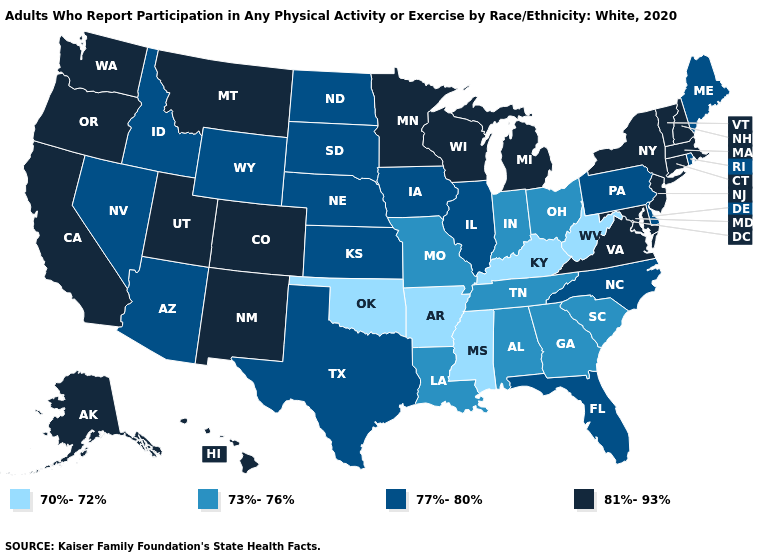What is the value of Montana?
Give a very brief answer. 81%-93%. Name the states that have a value in the range 70%-72%?
Keep it brief. Arkansas, Kentucky, Mississippi, Oklahoma, West Virginia. Name the states that have a value in the range 77%-80%?
Answer briefly. Arizona, Delaware, Florida, Idaho, Illinois, Iowa, Kansas, Maine, Nebraska, Nevada, North Carolina, North Dakota, Pennsylvania, Rhode Island, South Dakota, Texas, Wyoming. What is the value of North Carolina?
Give a very brief answer. 77%-80%. Name the states that have a value in the range 70%-72%?
Answer briefly. Arkansas, Kentucky, Mississippi, Oklahoma, West Virginia. Which states have the lowest value in the USA?
Be succinct. Arkansas, Kentucky, Mississippi, Oklahoma, West Virginia. Does Mississippi have a higher value than New Hampshire?
Be succinct. No. What is the value of Montana?
Be succinct. 81%-93%. Which states have the lowest value in the South?
Be succinct. Arkansas, Kentucky, Mississippi, Oklahoma, West Virginia. Which states hav the highest value in the Northeast?
Short answer required. Connecticut, Massachusetts, New Hampshire, New Jersey, New York, Vermont. Is the legend a continuous bar?
Concise answer only. No. What is the highest value in states that border Illinois?
Answer briefly. 81%-93%. What is the value of California?
Be succinct. 81%-93%. What is the highest value in the USA?
Write a very short answer. 81%-93%. Does Wisconsin have a higher value than Alabama?
Short answer required. Yes. 